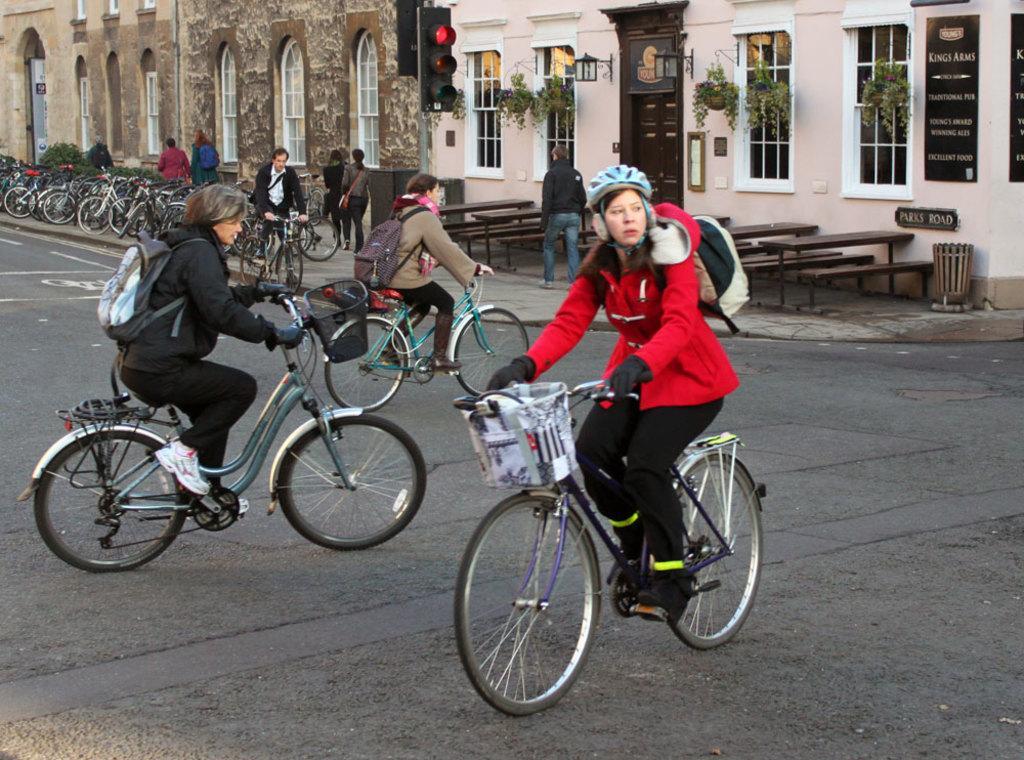In one or two sentences, can you explain what this image depicts? There are three women cycling a bicycle. Two of them on the same direction and the one is in opposite direction. In the background there are some cycles parked there. We can see a signal light pole and a building in the background. 